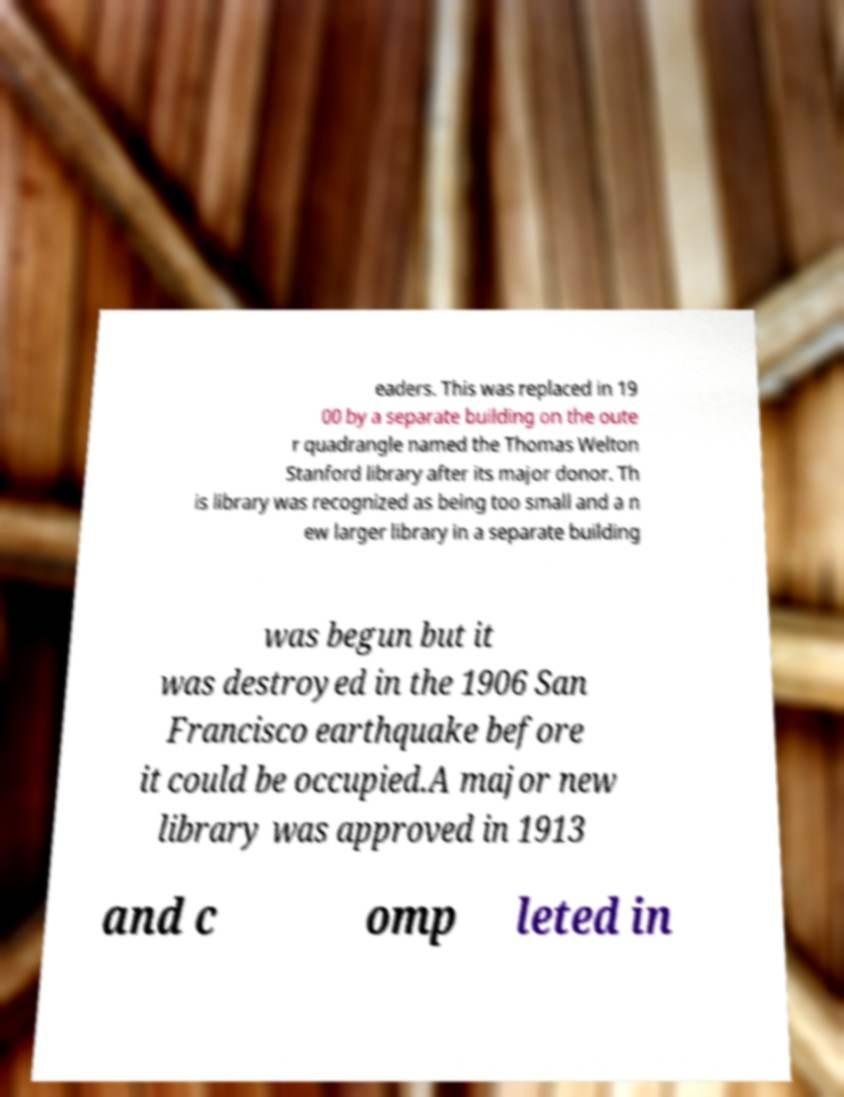Could you extract and type out the text from this image? eaders. This was replaced in 19 00 by a separate building on the oute r quadrangle named the Thomas Welton Stanford library after its major donor. Th is library was recognized as being too small and a n ew larger library in a separate building was begun but it was destroyed in the 1906 San Francisco earthquake before it could be occupied.A major new library was approved in 1913 and c omp leted in 